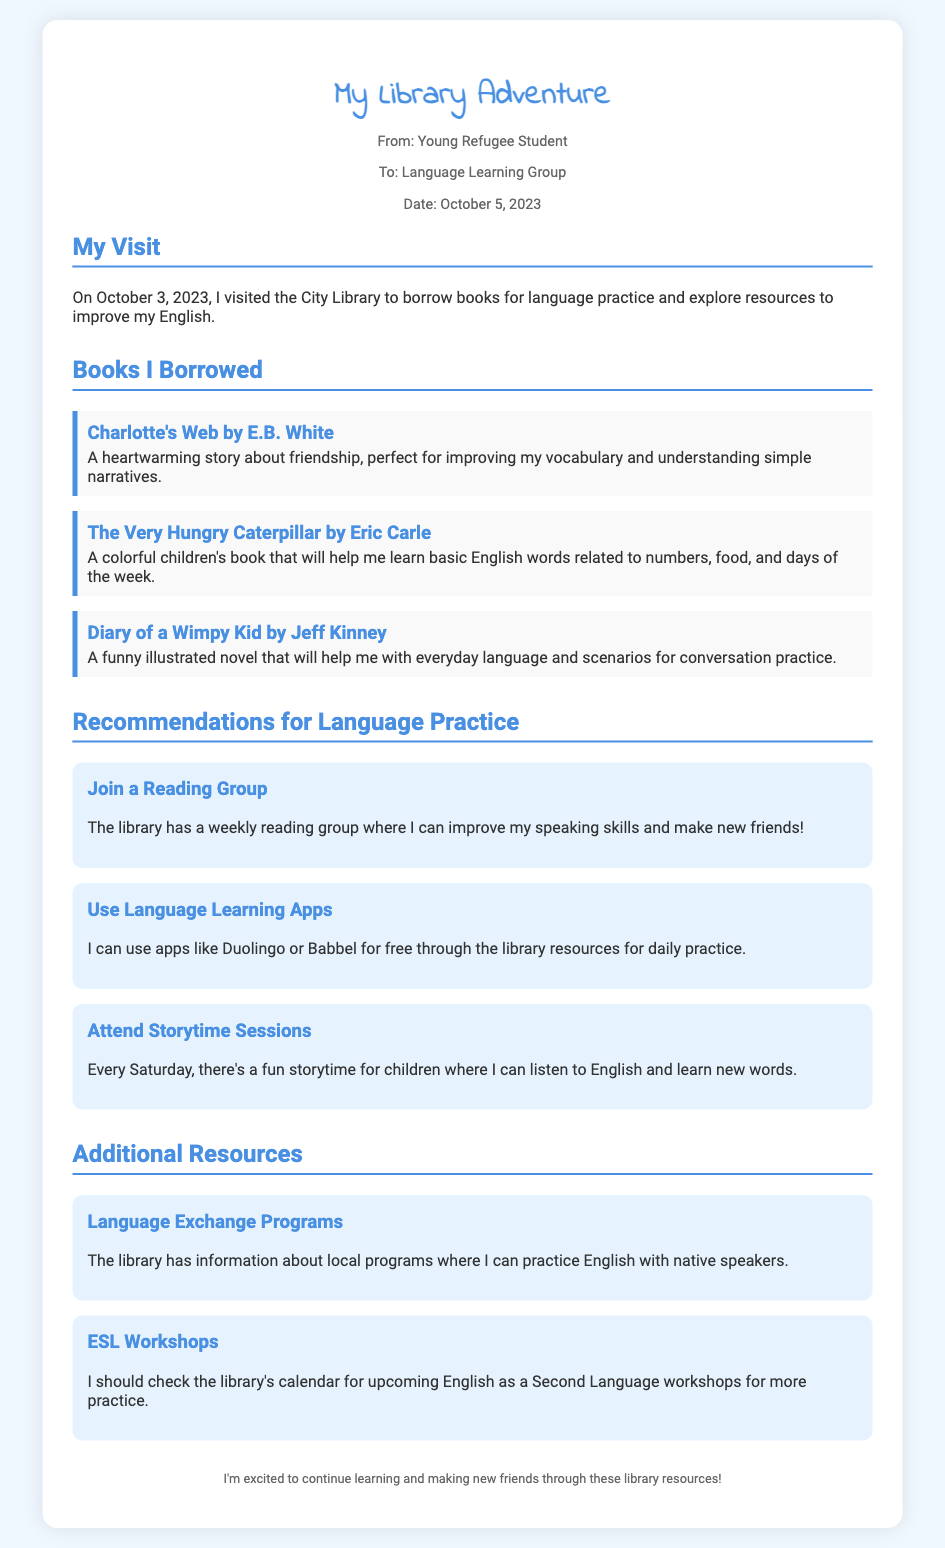What date did the library visit occur? The date of the library visit is mentioned as October 3, 2023.
Answer: October 3, 2023 Who is the author of "Charlotte's Web"? The author of "Charlotte's Web" is E.B. White, as stated in the document's section on borrowed books.
Answer: E.B. White What type of book is "The Very Hungry Caterpillar"? It is described as a colorful children's book to learn basic English words.
Answer: Colorful children's book What is a recommended activity to improve speaking skills? Joining a reading group is suggested as a way to improve speaking skills and make friends.
Answer: Join a reading group How often does the storytime session occur? The document states that the storytime session occurs every Saturday.
Answer: Every Saturday What resources can be used for daily practice? The memo recommends using language learning apps like Duolingo or Babbel for daily practice.
Answer: Language learning apps How does the author feel about using library resources? The author expresses excitement about continuing to learn and make friends through library resources.
Answer: Excited What workshop type should be checked for more practice? ESL workshops are mentioned as useful for more practice in the document.
Answer: ESL workshops 